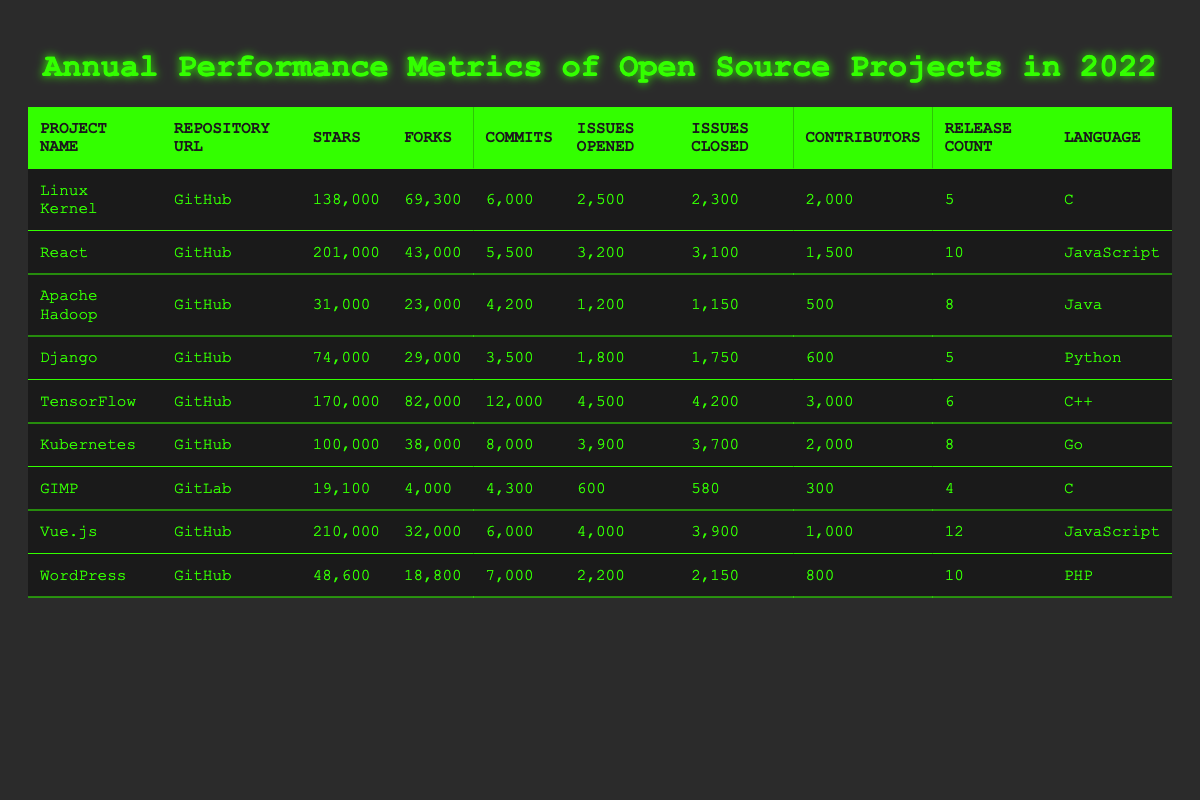What open source project has the highest number of stars? By looking at the "Stars" column, we can see that "Vue.js" has the highest value, with 210,000 stars, which is greater than all other projects listed.
Answer: Vue.js Which project has the most contributors? From the "Contributors" column, "TensorFlow" has 3,000 contributors, which is more than any other project in the table.
Answer: TensorFlow How many total issues were opened across all projects? To find the total, we sum the values in the "Issues Opened" column: 2,500 + 3,200 + 1,200 + 1,800 + 4,500 + 3,900 + 600 + 4,000 + 2,200 = 24,100.
Answer: 24,100 Which programming language has the most open source projects listed? By counting the unique languages in the "Language" column, we see that JavaScript appears 3 times (React, Vue.js), while other languages (C, Java, Python, C++, Go, PHP) appear once or twice. Thus, JavaScript has the most.
Answer: JavaScript What is the average number of forks across all projects? First, we sum the values in the "Forks" column: 69,300 + 43,000 + 23,000 + 29,000 + 82,000 + 38,000 + 4,000 + 32,000 + 18,800 = 338,100. Then, we divide by the number of projects (9), which gives 338,100 / 9 ≈ 37,577.78.
Answer: ~37,577 Did any project have more issues closed than opened? We check the "Issues Opened" and "Issues Closed" columns for each project. All listed projects have closed more issues than opened except for "GIMP", which has 580 closed vs 600 opened. So, this statement is true for all but GIMP.
Answer: Yes, except GIMP How many releases did the Linux Kernel project have? The value in the "Release Count" column for the Linux Kernel project is 5.
Answer: 5 Which project had the fewest stars? Looking at the "Stars" column, "GIMP" has the lowest value with 19,100 stars, making it the project with the fewest stars.
Answer: GIMP What is the difference between the number of issues opened and closed for TensorFlow? For TensorFlow, there are 4,500 issues opened and 4,200 issues closed. The difference is 4,500 - 4,200 = 300.
Answer: 300 Which project had the most commits and what was the number? By checking the "Commits" column, "TensorFlow" has the most commits with a total of 12,000, which is more than any other project listed.
Answer: TensorFlow, 12,000 